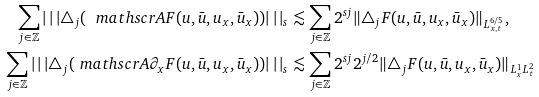Convert formula to latex. <formula><loc_0><loc_0><loc_500><loc_500>\sum _ { j \in \mathbb { Z } } | \, | \, | \triangle _ { j } ( \ m a t h s c r { A } F ( u , \bar { u } , u _ { x } , \bar { u } _ { x } ) ) | \, | \, | _ { s } & \lesssim \sum _ { j \in \mathbb { Z } } 2 ^ { s j } \| \triangle _ { j } F ( u , \bar { u } , u _ { x } , \bar { u } _ { x } ) \| _ { L ^ { 6 / 5 } _ { x , t } } , \\ \sum _ { j \in \mathbb { Z } } | \, | \, | \triangle _ { j } ( \ m a t h s c r { A } \partial _ { x } F ( u , \bar { u } , u _ { x } , \bar { u } _ { x } ) ) | \, | \, | _ { s } & \lesssim \sum _ { j \in \mathbb { Z } } 2 ^ { s j } 2 ^ { j / 2 } \| \triangle _ { j } F ( u , \bar { u } , u _ { x } , \bar { u } _ { x } ) \| _ { L ^ { 1 } _ { x } L ^ { 2 } _ { t } }</formula> 